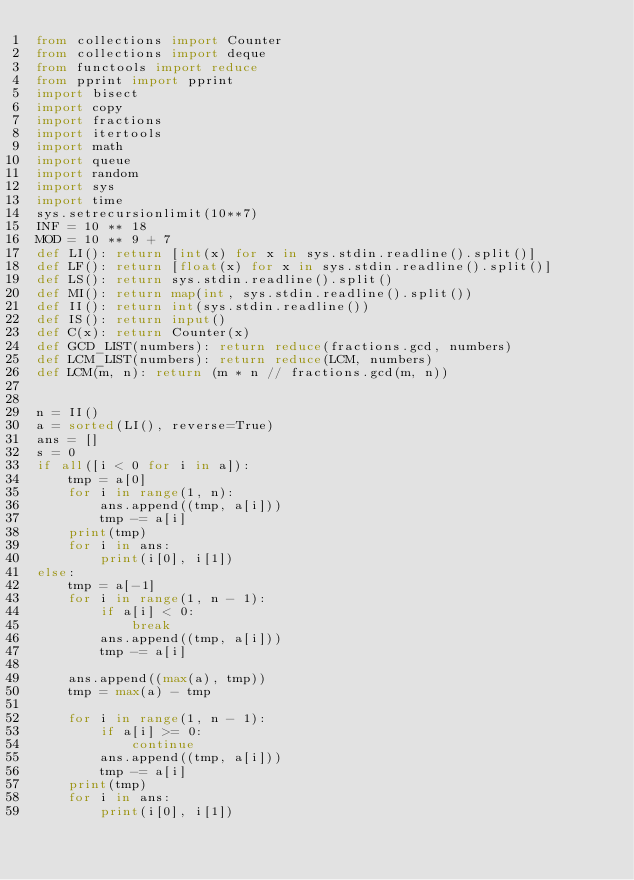<code> <loc_0><loc_0><loc_500><loc_500><_Python_>from collections import Counter
from collections import deque
from functools import reduce
from pprint import pprint
import bisect
import copy
import fractions
import itertools
import math
import queue
import random
import sys
import time
sys.setrecursionlimit(10**7)
INF = 10 ** 18
MOD = 10 ** 9 + 7
def LI(): return [int(x) for x in sys.stdin.readline().split()]
def LF(): return [float(x) for x in sys.stdin.readline().split()]
def LS(): return sys.stdin.readline().split()
def MI(): return map(int, sys.stdin.readline().split())
def II(): return int(sys.stdin.readline())
def IS(): return input()
def C(x): return Counter(x)
def GCD_LIST(numbers): return reduce(fractions.gcd, numbers)
def LCM_LIST(numbers): return reduce(LCM, numbers)
def LCM(m, n): return (m * n // fractions.gcd(m, n))


n = II()
a = sorted(LI(), reverse=True)
ans = []
s = 0
if all([i < 0 for i in a]):
    tmp = a[0]
    for i in range(1, n):
        ans.append((tmp, a[i]))
        tmp -= a[i]
    print(tmp)
    for i in ans:
        print(i[0], i[1])
else:
    tmp = a[-1]
    for i in range(1, n - 1):
        if a[i] < 0:
            break
        ans.append((tmp, a[i]))
        tmp -= a[i]

    ans.append((max(a), tmp))
    tmp = max(a) - tmp

    for i in range(1, n - 1):
        if a[i] >= 0:
            continue
        ans.append((tmp, a[i]))
        tmp -= a[i]
    print(tmp)
    for i in ans:
        print(i[0], i[1])
</code> 